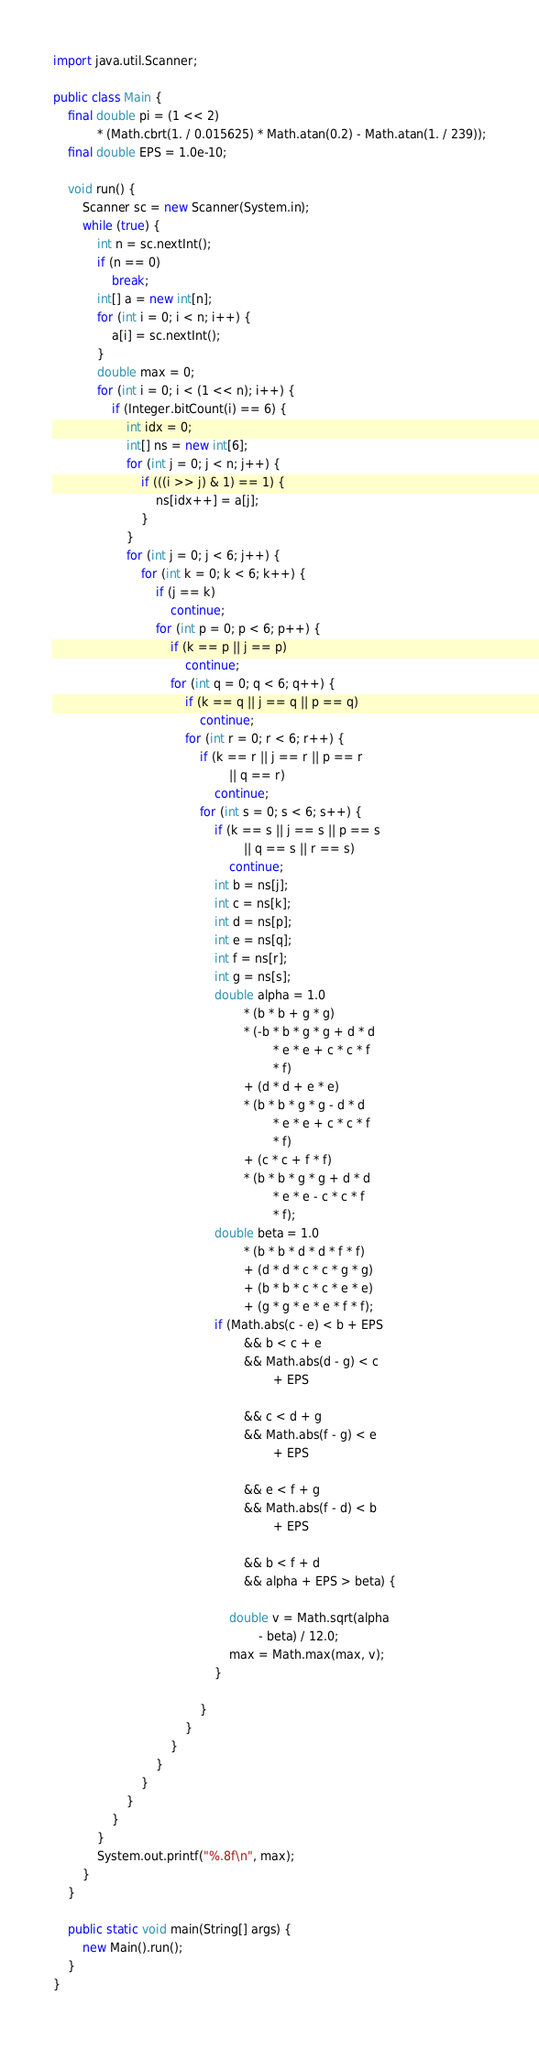<code> <loc_0><loc_0><loc_500><loc_500><_Java_>import java.util.Scanner;

public class Main {
    final double pi = (1 << 2)
            * (Math.cbrt(1. / 0.015625) * Math.atan(0.2) - Math.atan(1. / 239));
    final double EPS = 1.0e-10;

    void run() {
        Scanner sc = new Scanner(System.in);
        while (true) {
            int n = sc.nextInt();
            if (n == 0)
                break;
            int[] a = new int[n];
            for (int i = 0; i < n; i++) {
                a[i] = sc.nextInt();
            }
            double max = 0;
            for (int i = 0; i < (1 << n); i++) {
                if (Integer.bitCount(i) == 6) {
                    int idx = 0;
                    int[] ns = new int[6];
                    for (int j = 0; j < n; j++) {
                        if (((i >> j) & 1) == 1) {
                            ns[idx++] = a[j];
                        }
                    }
                    for (int j = 0; j < 6; j++) {
                        for (int k = 0; k < 6; k++) {
                            if (j == k)
                                continue;
                            for (int p = 0; p < 6; p++) {
                                if (k == p || j == p)
                                    continue;
                                for (int q = 0; q < 6; q++) {
                                    if (k == q || j == q || p == q)
                                        continue;
                                    for (int r = 0; r < 6; r++) {
                                        if (k == r || j == r || p == r
                                                || q == r)
                                            continue;
                                        for (int s = 0; s < 6; s++) {
                                            if (k == s || j == s || p == s
                                                    || q == s || r == s)
                                                continue;
                                            int b = ns[j];
                                            int c = ns[k];
                                            int d = ns[p];
                                            int e = ns[q];
                                            int f = ns[r];
                                            int g = ns[s];
                                            double alpha = 1.0
                                                    * (b * b + g * g)
                                                    * (-b * b * g * g + d * d
                                                            * e * e + c * c * f
                                                            * f)
                                                    + (d * d + e * e)
                                                    * (b * b * g * g - d * d
                                                            * e * e + c * c * f
                                                            * f)
                                                    + (c * c + f * f)
                                                    * (b * b * g * g + d * d
                                                            * e * e - c * c * f
                                                            * f);
                                            double beta = 1.0
                                                    * (b * b * d * d * f * f)
                                                    + (d * d * c * c * g * g)
                                                    + (b * b * c * c * e * e)
                                                    + (g * g * e * e * f * f);
                                            if (Math.abs(c - e) < b + EPS
                                                    && b < c + e
                                                    && Math.abs(d - g) < c
                                                            + EPS

                                                    && c < d + g
                                                    && Math.abs(f - g) < e
                                                            + EPS

                                                    && e < f + g
                                                    && Math.abs(f - d) < b
                                                            + EPS

                                                    && b < f + d
                                                    && alpha + EPS > beta) {

                                                double v = Math.sqrt(alpha
                                                        - beta) / 12.0;
                                                max = Math.max(max, v);
                                            }

                                        }
                                    }
                                }
                            }
                        }
                    }
                }
            }
            System.out.printf("%.8f\n", max);
        }
    }

    public static void main(String[] args) {
        new Main().run();
    }
}</code> 